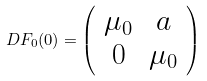<formula> <loc_0><loc_0><loc_500><loc_500>D F _ { 0 } ( 0 ) = \left ( \begin{array} { c c } \mu _ { 0 } & a \\ 0 & \mu _ { 0 } \end{array} \right )</formula> 